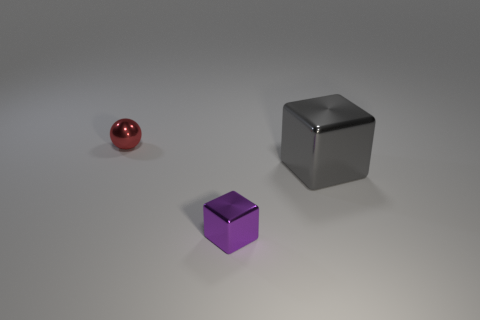Add 1 small purple things. How many objects exist? 4 Subtract all blocks. How many objects are left? 1 Add 1 big cubes. How many big cubes are left? 2 Add 2 purple metal objects. How many purple metal objects exist? 3 Subtract 0 yellow cylinders. How many objects are left? 3 Subtract all cyan cylinders. Subtract all large metal blocks. How many objects are left? 2 